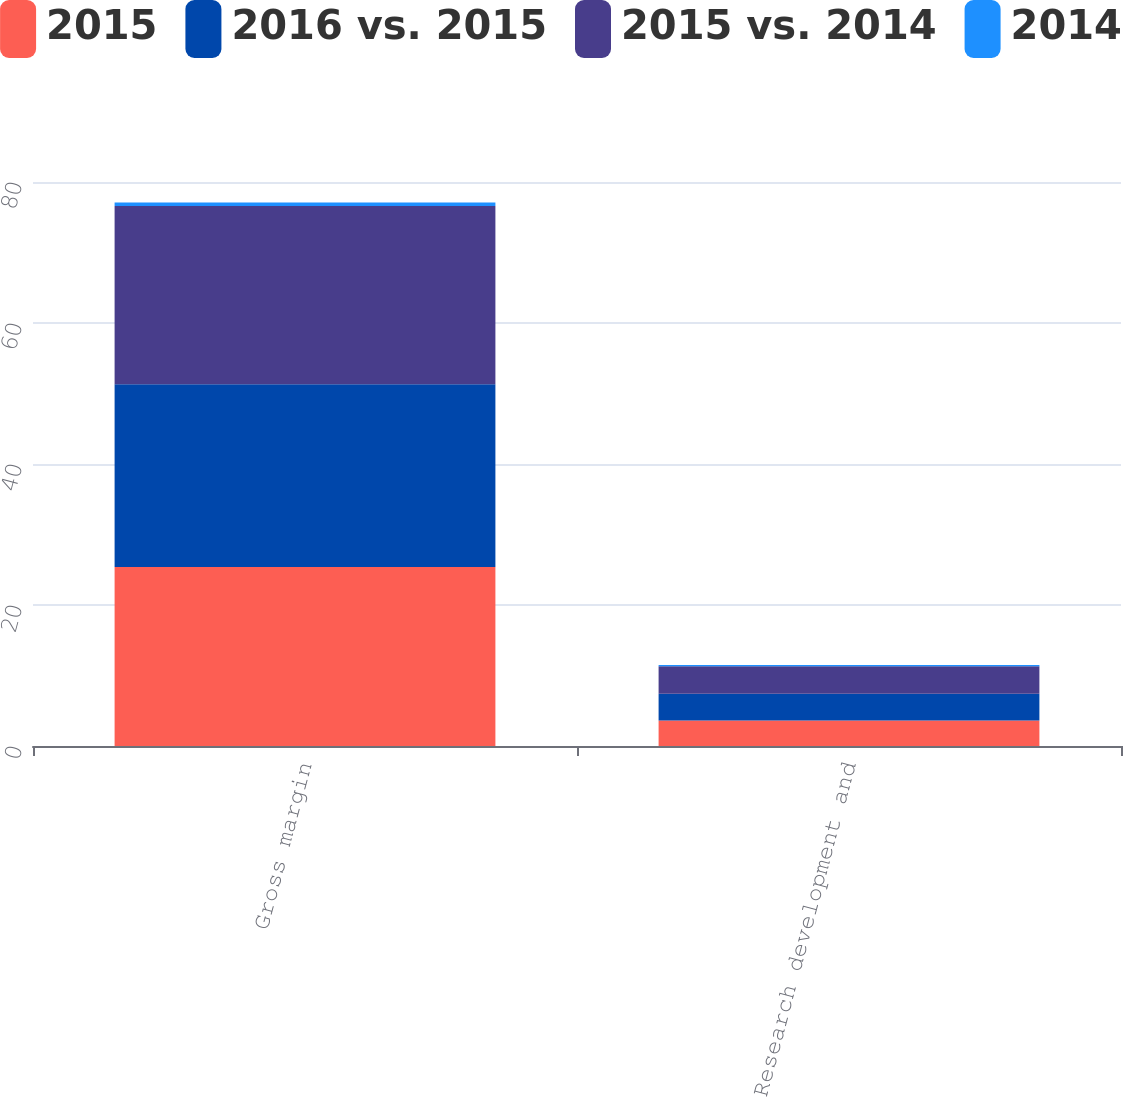Convert chart. <chart><loc_0><loc_0><loc_500><loc_500><stacked_bar_chart><ecel><fcel>Gross margin<fcel>Research development and<nl><fcel>2015<fcel>25.4<fcel>3.6<nl><fcel>2016 vs. 2015<fcel>25.9<fcel>3.8<nl><fcel>2015 vs. 2014<fcel>25.3<fcel>3.9<nl><fcel>2014<fcel>0.5<fcel>0.2<nl></chart> 